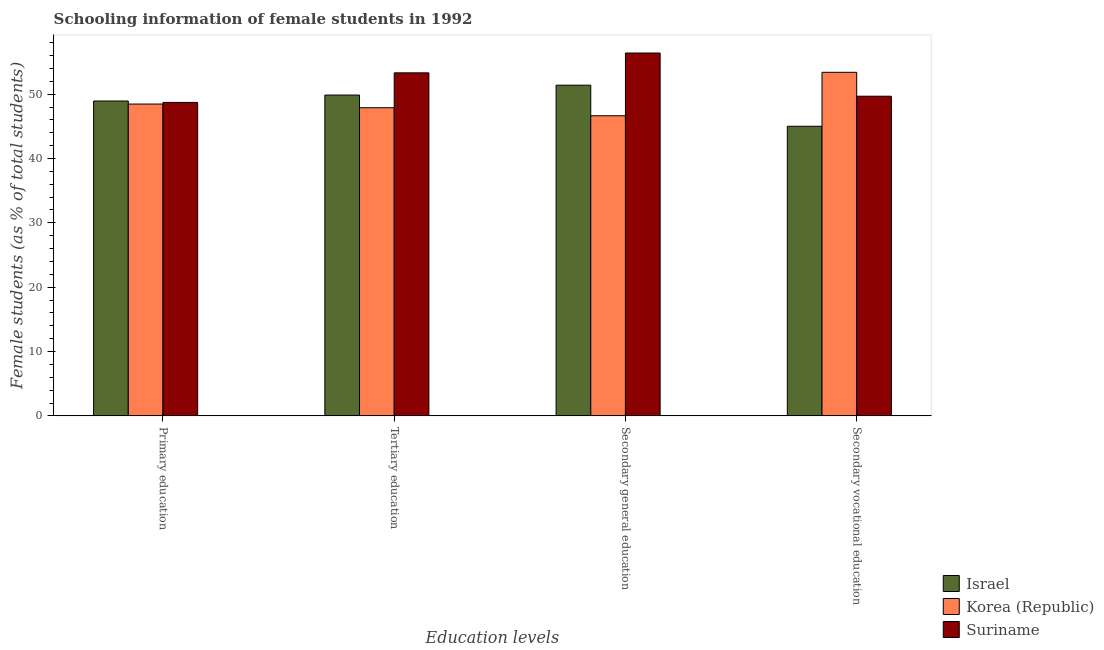How many different coloured bars are there?
Make the answer very short. 3. How many groups of bars are there?
Your answer should be very brief. 4. Are the number of bars on each tick of the X-axis equal?
Offer a very short reply. Yes. How many bars are there on the 4th tick from the left?
Your response must be concise. 3. How many bars are there on the 1st tick from the right?
Give a very brief answer. 3. What is the percentage of female students in secondary education in Israel?
Give a very brief answer. 51.4. Across all countries, what is the maximum percentage of female students in primary education?
Ensure brevity in your answer.  48.94. Across all countries, what is the minimum percentage of female students in tertiary education?
Provide a succinct answer. 47.89. In which country was the percentage of female students in tertiary education maximum?
Keep it short and to the point. Suriname. What is the total percentage of female students in tertiary education in the graph?
Your answer should be compact. 151.07. What is the difference between the percentage of female students in secondary vocational education in Suriname and that in Korea (Republic)?
Your answer should be very brief. -3.72. What is the difference between the percentage of female students in tertiary education in Israel and the percentage of female students in primary education in Korea (Republic)?
Your response must be concise. 1.4. What is the average percentage of female students in secondary education per country?
Your answer should be compact. 51.48. What is the difference between the percentage of female students in secondary education and percentage of female students in tertiary education in Suriname?
Give a very brief answer. 3.08. In how many countries, is the percentage of female students in secondary vocational education greater than 10 %?
Your response must be concise. 3. What is the ratio of the percentage of female students in secondary education in Korea (Republic) to that in Suriname?
Make the answer very short. 0.83. Is the percentage of female students in primary education in Israel less than that in Korea (Republic)?
Keep it short and to the point. No. Is the difference between the percentage of female students in tertiary education in Israel and Korea (Republic) greater than the difference between the percentage of female students in secondary vocational education in Israel and Korea (Republic)?
Provide a short and direct response. Yes. What is the difference between the highest and the second highest percentage of female students in primary education?
Provide a succinct answer. 0.22. What is the difference between the highest and the lowest percentage of female students in primary education?
Offer a terse response. 0.47. In how many countries, is the percentage of female students in tertiary education greater than the average percentage of female students in tertiary education taken over all countries?
Give a very brief answer. 1. Is it the case that in every country, the sum of the percentage of female students in tertiary education and percentage of female students in secondary vocational education is greater than the sum of percentage of female students in secondary education and percentage of female students in primary education?
Offer a terse response. No. Is it the case that in every country, the sum of the percentage of female students in primary education and percentage of female students in tertiary education is greater than the percentage of female students in secondary education?
Your answer should be compact. Yes. Are all the bars in the graph horizontal?
Provide a short and direct response. No. How many countries are there in the graph?
Your answer should be compact. 3. What is the difference between two consecutive major ticks on the Y-axis?
Offer a terse response. 10. Are the values on the major ticks of Y-axis written in scientific E-notation?
Provide a succinct answer. No. Does the graph contain any zero values?
Ensure brevity in your answer.  No. Where does the legend appear in the graph?
Give a very brief answer. Bottom right. How are the legend labels stacked?
Ensure brevity in your answer.  Vertical. What is the title of the graph?
Provide a short and direct response. Schooling information of female students in 1992. Does "South Sudan" appear as one of the legend labels in the graph?
Your answer should be very brief. No. What is the label or title of the X-axis?
Provide a succinct answer. Education levels. What is the label or title of the Y-axis?
Your answer should be compact. Female students (as % of total students). What is the Female students (as % of total students) of Israel in Primary education?
Offer a very short reply. 48.94. What is the Female students (as % of total students) of Korea (Republic) in Primary education?
Your answer should be very brief. 48.47. What is the Female students (as % of total students) of Suriname in Primary education?
Provide a short and direct response. 48.72. What is the Female students (as % of total students) in Israel in Tertiary education?
Offer a very short reply. 49.87. What is the Female students (as % of total students) in Korea (Republic) in Tertiary education?
Keep it short and to the point. 47.89. What is the Female students (as % of total students) in Suriname in Tertiary education?
Give a very brief answer. 53.32. What is the Female students (as % of total students) in Israel in Secondary general education?
Provide a succinct answer. 51.4. What is the Female students (as % of total students) of Korea (Republic) in Secondary general education?
Make the answer very short. 46.65. What is the Female students (as % of total students) of Suriname in Secondary general education?
Make the answer very short. 56.4. What is the Female students (as % of total students) of Israel in Secondary vocational education?
Ensure brevity in your answer.  45.01. What is the Female students (as % of total students) in Korea (Republic) in Secondary vocational education?
Offer a terse response. 53.4. What is the Female students (as % of total students) of Suriname in Secondary vocational education?
Ensure brevity in your answer.  49.68. Across all Education levels, what is the maximum Female students (as % of total students) of Israel?
Give a very brief answer. 51.4. Across all Education levels, what is the maximum Female students (as % of total students) of Korea (Republic)?
Provide a succinct answer. 53.4. Across all Education levels, what is the maximum Female students (as % of total students) in Suriname?
Your answer should be compact. 56.4. Across all Education levels, what is the minimum Female students (as % of total students) of Israel?
Ensure brevity in your answer.  45.01. Across all Education levels, what is the minimum Female students (as % of total students) in Korea (Republic)?
Provide a succinct answer. 46.65. Across all Education levels, what is the minimum Female students (as % of total students) in Suriname?
Offer a very short reply. 48.72. What is the total Female students (as % of total students) in Israel in the graph?
Offer a terse response. 195.22. What is the total Female students (as % of total students) of Korea (Republic) in the graph?
Keep it short and to the point. 196.4. What is the total Female students (as % of total students) in Suriname in the graph?
Make the answer very short. 208.12. What is the difference between the Female students (as % of total students) in Israel in Primary education and that in Tertiary education?
Provide a short and direct response. -0.93. What is the difference between the Female students (as % of total students) of Korea (Republic) in Primary education and that in Tertiary education?
Your response must be concise. 0.58. What is the difference between the Female students (as % of total students) of Suriname in Primary education and that in Tertiary education?
Your response must be concise. -4.6. What is the difference between the Female students (as % of total students) of Israel in Primary education and that in Secondary general education?
Your answer should be very brief. -2.46. What is the difference between the Female students (as % of total students) in Korea (Republic) in Primary education and that in Secondary general education?
Your answer should be compact. 1.82. What is the difference between the Female students (as % of total students) of Suriname in Primary education and that in Secondary general education?
Provide a succinct answer. -7.68. What is the difference between the Female students (as % of total students) in Israel in Primary education and that in Secondary vocational education?
Ensure brevity in your answer.  3.92. What is the difference between the Female students (as % of total students) in Korea (Republic) in Primary education and that in Secondary vocational education?
Your response must be concise. -4.93. What is the difference between the Female students (as % of total students) in Suriname in Primary education and that in Secondary vocational education?
Your answer should be very brief. -0.97. What is the difference between the Female students (as % of total students) in Israel in Tertiary education and that in Secondary general education?
Offer a very short reply. -1.53. What is the difference between the Female students (as % of total students) in Korea (Republic) in Tertiary education and that in Secondary general education?
Offer a very short reply. 1.25. What is the difference between the Female students (as % of total students) in Suriname in Tertiary education and that in Secondary general education?
Your answer should be very brief. -3.08. What is the difference between the Female students (as % of total students) of Israel in Tertiary education and that in Secondary vocational education?
Make the answer very short. 4.85. What is the difference between the Female students (as % of total students) in Korea (Republic) in Tertiary education and that in Secondary vocational education?
Your answer should be very brief. -5.51. What is the difference between the Female students (as % of total students) in Suriname in Tertiary education and that in Secondary vocational education?
Provide a short and direct response. 3.63. What is the difference between the Female students (as % of total students) of Israel in Secondary general education and that in Secondary vocational education?
Your answer should be very brief. 6.38. What is the difference between the Female students (as % of total students) of Korea (Republic) in Secondary general education and that in Secondary vocational education?
Your response must be concise. -6.75. What is the difference between the Female students (as % of total students) in Suriname in Secondary general education and that in Secondary vocational education?
Provide a short and direct response. 6.71. What is the difference between the Female students (as % of total students) of Israel in Primary education and the Female students (as % of total students) of Korea (Republic) in Tertiary education?
Give a very brief answer. 1.05. What is the difference between the Female students (as % of total students) in Israel in Primary education and the Female students (as % of total students) in Suriname in Tertiary education?
Keep it short and to the point. -4.38. What is the difference between the Female students (as % of total students) of Korea (Republic) in Primary education and the Female students (as % of total students) of Suriname in Tertiary education?
Offer a very short reply. -4.85. What is the difference between the Female students (as % of total students) of Israel in Primary education and the Female students (as % of total students) of Korea (Republic) in Secondary general education?
Ensure brevity in your answer.  2.29. What is the difference between the Female students (as % of total students) in Israel in Primary education and the Female students (as % of total students) in Suriname in Secondary general education?
Give a very brief answer. -7.46. What is the difference between the Female students (as % of total students) in Korea (Republic) in Primary education and the Female students (as % of total students) in Suriname in Secondary general education?
Your answer should be very brief. -7.93. What is the difference between the Female students (as % of total students) of Israel in Primary education and the Female students (as % of total students) of Korea (Republic) in Secondary vocational education?
Ensure brevity in your answer.  -4.46. What is the difference between the Female students (as % of total students) of Israel in Primary education and the Female students (as % of total students) of Suriname in Secondary vocational education?
Provide a succinct answer. -0.74. What is the difference between the Female students (as % of total students) of Korea (Republic) in Primary education and the Female students (as % of total students) of Suriname in Secondary vocational education?
Make the answer very short. -1.22. What is the difference between the Female students (as % of total students) in Israel in Tertiary education and the Female students (as % of total students) in Korea (Republic) in Secondary general education?
Give a very brief answer. 3.22. What is the difference between the Female students (as % of total students) in Israel in Tertiary education and the Female students (as % of total students) in Suriname in Secondary general education?
Your response must be concise. -6.53. What is the difference between the Female students (as % of total students) of Korea (Republic) in Tertiary education and the Female students (as % of total students) of Suriname in Secondary general education?
Your answer should be very brief. -8.51. What is the difference between the Female students (as % of total students) of Israel in Tertiary education and the Female students (as % of total students) of Korea (Republic) in Secondary vocational education?
Provide a short and direct response. -3.53. What is the difference between the Female students (as % of total students) of Israel in Tertiary education and the Female students (as % of total students) of Suriname in Secondary vocational education?
Ensure brevity in your answer.  0.18. What is the difference between the Female students (as % of total students) of Korea (Republic) in Tertiary education and the Female students (as % of total students) of Suriname in Secondary vocational education?
Your answer should be compact. -1.79. What is the difference between the Female students (as % of total students) of Israel in Secondary general education and the Female students (as % of total students) of Korea (Republic) in Secondary vocational education?
Provide a succinct answer. -2. What is the difference between the Female students (as % of total students) in Israel in Secondary general education and the Female students (as % of total students) in Suriname in Secondary vocational education?
Your answer should be very brief. 1.71. What is the difference between the Female students (as % of total students) of Korea (Republic) in Secondary general education and the Female students (as % of total students) of Suriname in Secondary vocational education?
Provide a short and direct response. -3.04. What is the average Female students (as % of total students) of Israel per Education levels?
Ensure brevity in your answer.  48.8. What is the average Female students (as % of total students) in Korea (Republic) per Education levels?
Your answer should be very brief. 49.1. What is the average Female students (as % of total students) in Suriname per Education levels?
Your answer should be very brief. 52.03. What is the difference between the Female students (as % of total students) of Israel and Female students (as % of total students) of Korea (Republic) in Primary education?
Your response must be concise. 0.47. What is the difference between the Female students (as % of total students) of Israel and Female students (as % of total students) of Suriname in Primary education?
Ensure brevity in your answer.  0.22. What is the difference between the Female students (as % of total students) in Korea (Republic) and Female students (as % of total students) in Suriname in Primary education?
Provide a short and direct response. -0.25. What is the difference between the Female students (as % of total students) of Israel and Female students (as % of total students) of Korea (Republic) in Tertiary education?
Give a very brief answer. 1.97. What is the difference between the Female students (as % of total students) of Israel and Female students (as % of total students) of Suriname in Tertiary education?
Your answer should be very brief. -3.45. What is the difference between the Female students (as % of total students) in Korea (Republic) and Female students (as % of total students) in Suriname in Tertiary education?
Provide a succinct answer. -5.43. What is the difference between the Female students (as % of total students) of Israel and Female students (as % of total students) of Korea (Republic) in Secondary general education?
Provide a succinct answer. 4.75. What is the difference between the Female students (as % of total students) in Israel and Female students (as % of total students) in Suriname in Secondary general education?
Provide a succinct answer. -5. What is the difference between the Female students (as % of total students) in Korea (Republic) and Female students (as % of total students) in Suriname in Secondary general education?
Provide a short and direct response. -9.75. What is the difference between the Female students (as % of total students) in Israel and Female students (as % of total students) in Korea (Republic) in Secondary vocational education?
Offer a terse response. -8.39. What is the difference between the Female students (as % of total students) in Israel and Female students (as % of total students) in Suriname in Secondary vocational education?
Your answer should be compact. -4.67. What is the difference between the Female students (as % of total students) of Korea (Republic) and Female students (as % of total students) of Suriname in Secondary vocational education?
Offer a terse response. 3.72. What is the ratio of the Female students (as % of total students) in Israel in Primary education to that in Tertiary education?
Give a very brief answer. 0.98. What is the ratio of the Female students (as % of total students) in Korea (Republic) in Primary education to that in Tertiary education?
Offer a terse response. 1.01. What is the ratio of the Female students (as % of total students) of Suriname in Primary education to that in Tertiary education?
Your answer should be very brief. 0.91. What is the ratio of the Female students (as % of total students) in Israel in Primary education to that in Secondary general education?
Your response must be concise. 0.95. What is the ratio of the Female students (as % of total students) of Korea (Republic) in Primary education to that in Secondary general education?
Give a very brief answer. 1.04. What is the ratio of the Female students (as % of total students) in Suriname in Primary education to that in Secondary general education?
Ensure brevity in your answer.  0.86. What is the ratio of the Female students (as % of total students) of Israel in Primary education to that in Secondary vocational education?
Your answer should be compact. 1.09. What is the ratio of the Female students (as % of total students) of Korea (Republic) in Primary education to that in Secondary vocational education?
Offer a terse response. 0.91. What is the ratio of the Female students (as % of total students) in Suriname in Primary education to that in Secondary vocational education?
Your answer should be very brief. 0.98. What is the ratio of the Female students (as % of total students) of Israel in Tertiary education to that in Secondary general education?
Give a very brief answer. 0.97. What is the ratio of the Female students (as % of total students) of Korea (Republic) in Tertiary education to that in Secondary general education?
Keep it short and to the point. 1.03. What is the ratio of the Female students (as % of total students) of Suriname in Tertiary education to that in Secondary general education?
Provide a succinct answer. 0.95. What is the ratio of the Female students (as % of total students) of Israel in Tertiary education to that in Secondary vocational education?
Give a very brief answer. 1.11. What is the ratio of the Female students (as % of total students) of Korea (Republic) in Tertiary education to that in Secondary vocational education?
Offer a very short reply. 0.9. What is the ratio of the Female students (as % of total students) of Suriname in Tertiary education to that in Secondary vocational education?
Your response must be concise. 1.07. What is the ratio of the Female students (as % of total students) of Israel in Secondary general education to that in Secondary vocational education?
Offer a very short reply. 1.14. What is the ratio of the Female students (as % of total students) of Korea (Republic) in Secondary general education to that in Secondary vocational education?
Offer a terse response. 0.87. What is the ratio of the Female students (as % of total students) in Suriname in Secondary general education to that in Secondary vocational education?
Provide a succinct answer. 1.14. What is the difference between the highest and the second highest Female students (as % of total students) of Israel?
Provide a short and direct response. 1.53. What is the difference between the highest and the second highest Female students (as % of total students) in Korea (Republic)?
Provide a succinct answer. 4.93. What is the difference between the highest and the second highest Female students (as % of total students) in Suriname?
Keep it short and to the point. 3.08. What is the difference between the highest and the lowest Female students (as % of total students) of Israel?
Ensure brevity in your answer.  6.38. What is the difference between the highest and the lowest Female students (as % of total students) of Korea (Republic)?
Offer a terse response. 6.75. What is the difference between the highest and the lowest Female students (as % of total students) in Suriname?
Your answer should be compact. 7.68. 